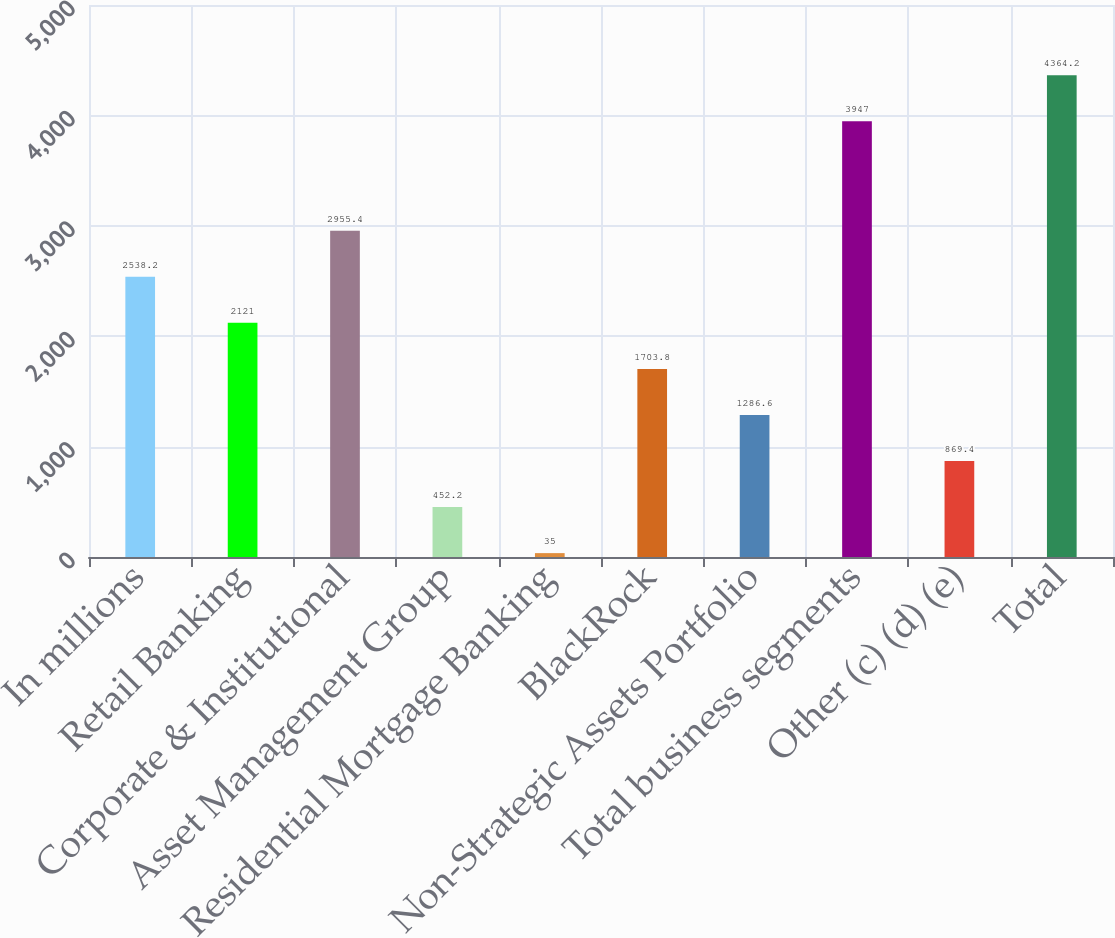<chart> <loc_0><loc_0><loc_500><loc_500><bar_chart><fcel>In millions<fcel>Retail Banking<fcel>Corporate & Institutional<fcel>Asset Management Group<fcel>Residential Mortgage Banking<fcel>BlackRock<fcel>Non-Strategic Assets Portfolio<fcel>Total business segments<fcel>Other (c) (d) (e)<fcel>Total<nl><fcel>2538.2<fcel>2121<fcel>2955.4<fcel>452.2<fcel>35<fcel>1703.8<fcel>1286.6<fcel>3947<fcel>869.4<fcel>4364.2<nl></chart> 